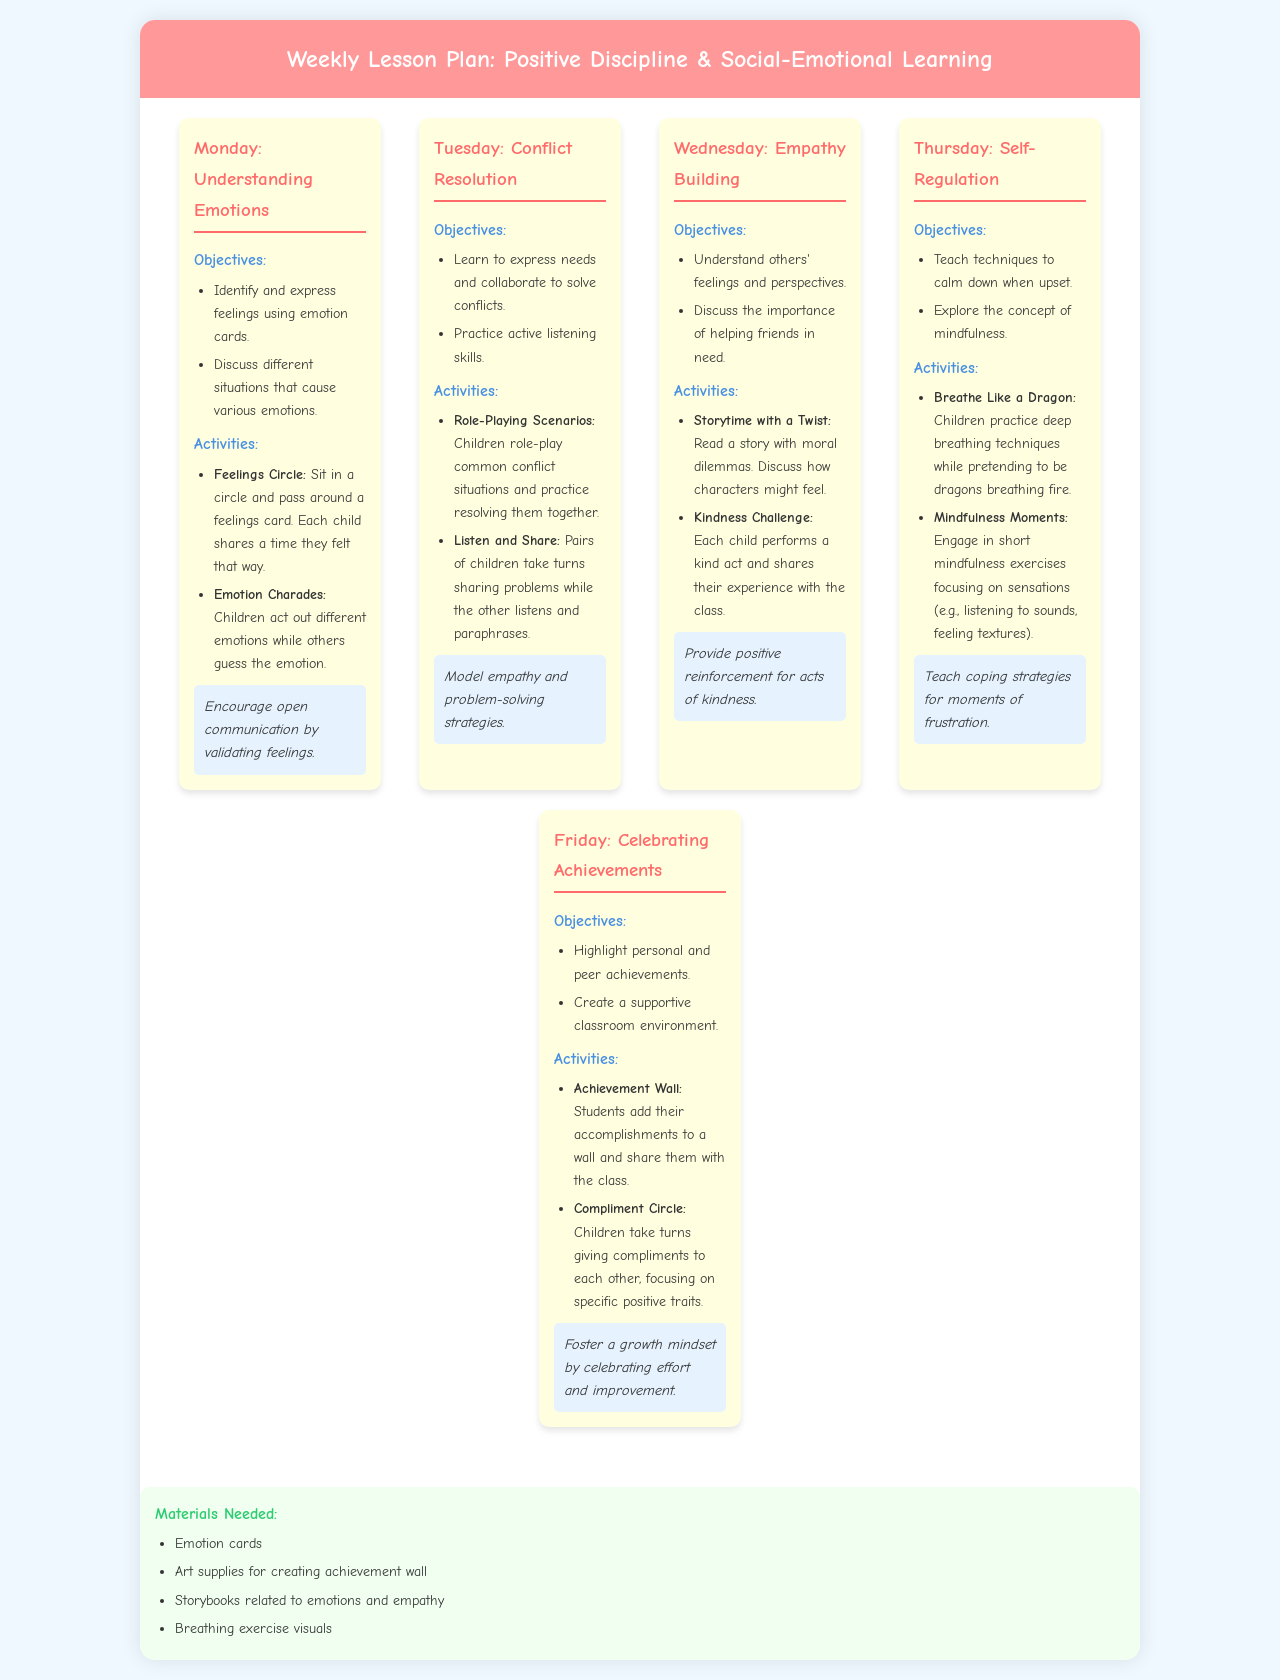What is the focus area for Monday? The focus area for Monday is Understanding Emotions, as indicated in the schedule for that day.
Answer: Understanding Emotions How many activities are proposed for Wednesday? There are two activities listed for Wednesday under the Empathy Building section of the document.
Answer: 2 What technique is emphasized on Tuesday? The technique emphasized on Tuesday is to model empathy and problem-solving strategies from the Conflict Resolution section.
Answer: Model empathy and problem-solving strategies What is the aim of the Kindness Challenge activity? The aim of the Kindness Challenge activity is for each child to perform a kind act and share their experience with the class, as stated in the Empathy Building section.
Answer: Each child performs a kind act How many materials are listed for the weekly lesson plan? The document lists four materials needed for the activities throughout the week.
Answer: 4 What goal is outlined for Friday? The goal outlined for Friday is to highlight personal and peer achievements.
Answer: Highlight personal and peer achievements Which day includes breathing exercises? Breathing exercises are included in the Thursday activities, focused on self-regulation techniques.
Answer: Thursday What is the primary objective of the Achievement Wall activity? The primary objective of the Achievement Wall activity is to allow students to add their accomplishments and share them, fostering a sense of achievement.
Answer: Create a supportive classroom environment 